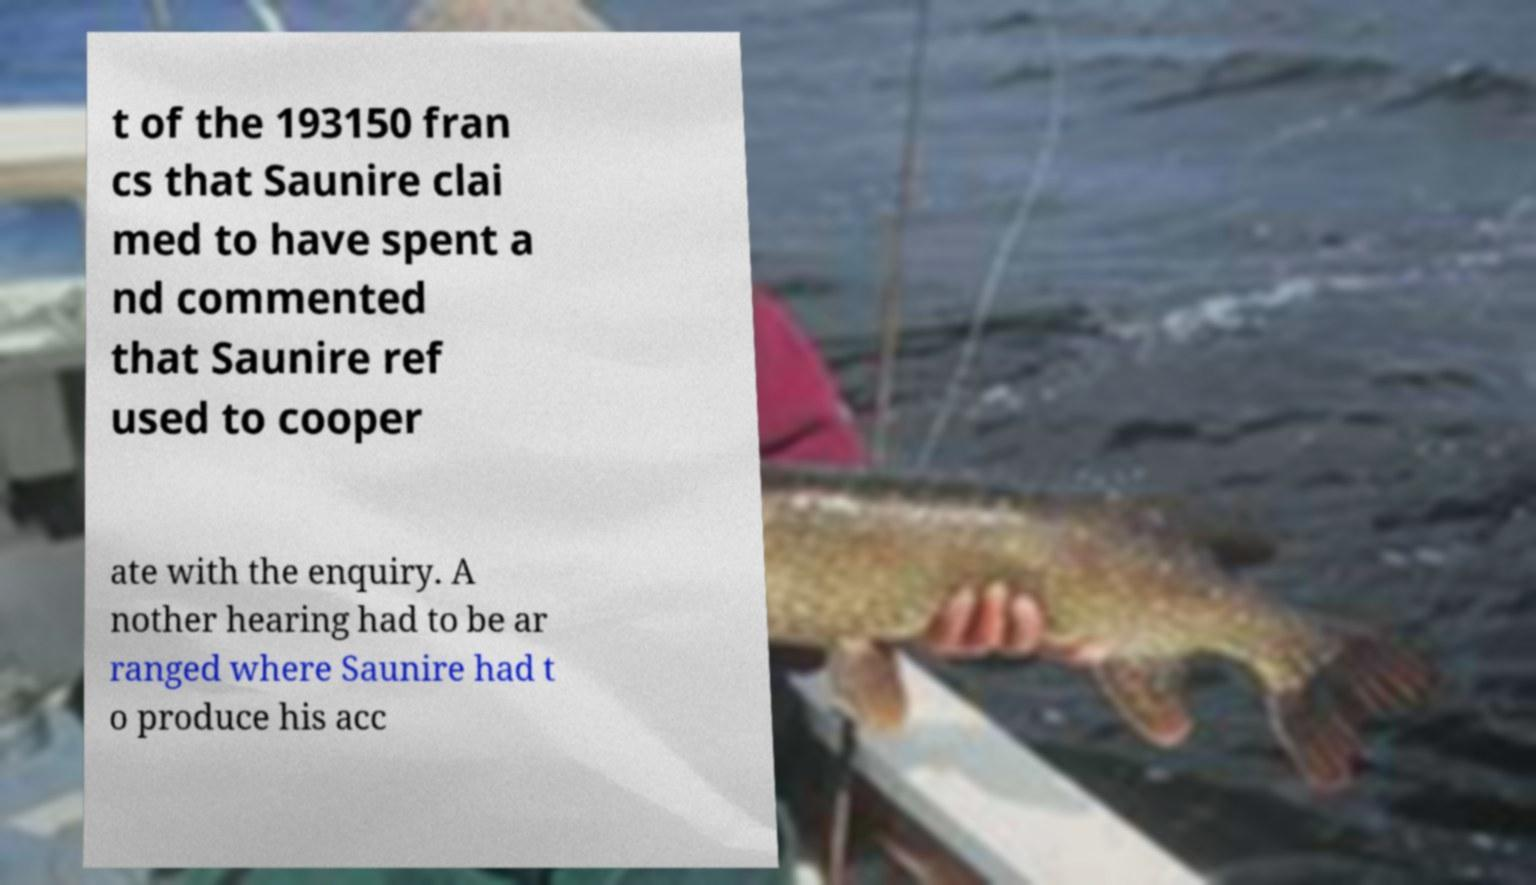For documentation purposes, I need the text within this image transcribed. Could you provide that? t of the 193150 fran cs that Saunire clai med to have spent a nd commented that Saunire ref used to cooper ate with the enquiry. A nother hearing had to be ar ranged where Saunire had t o produce his acc 